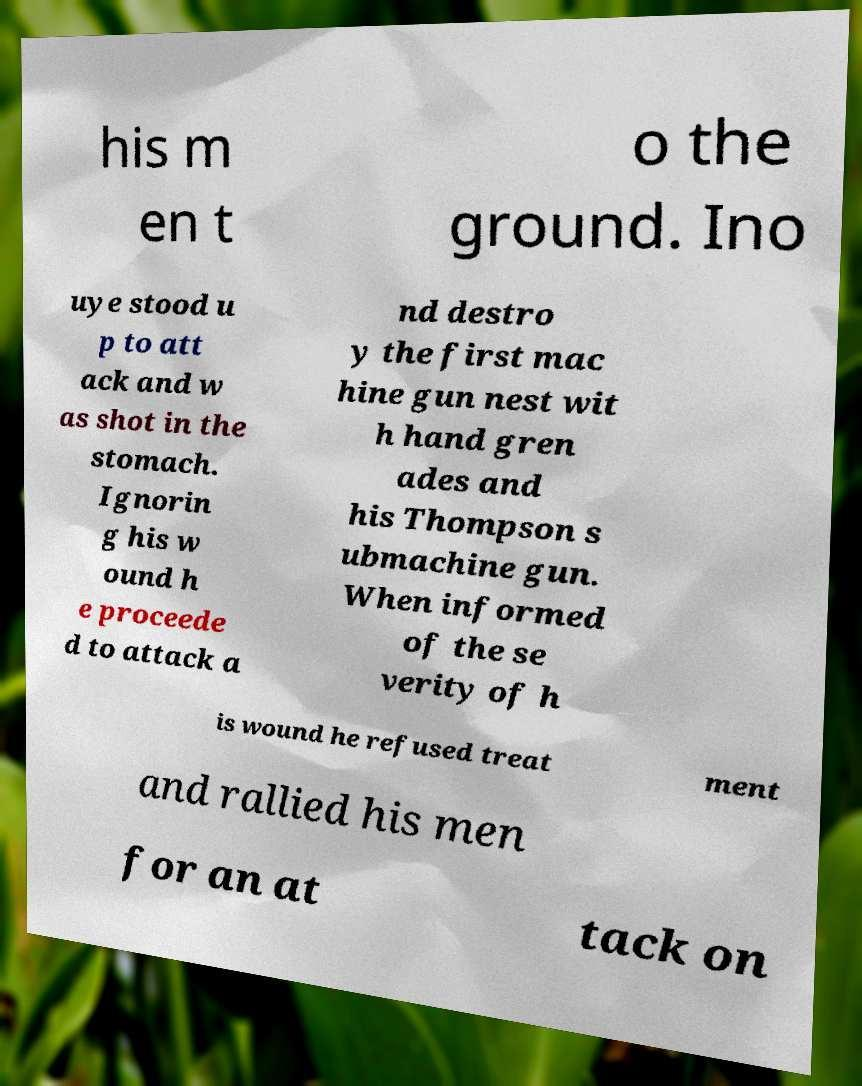I need the written content from this picture converted into text. Can you do that? his m en t o the ground. Ino uye stood u p to att ack and w as shot in the stomach. Ignorin g his w ound h e proceede d to attack a nd destro y the first mac hine gun nest wit h hand gren ades and his Thompson s ubmachine gun. When informed of the se verity of h is wound he refused treat ment and rallied his men for an at tack on 